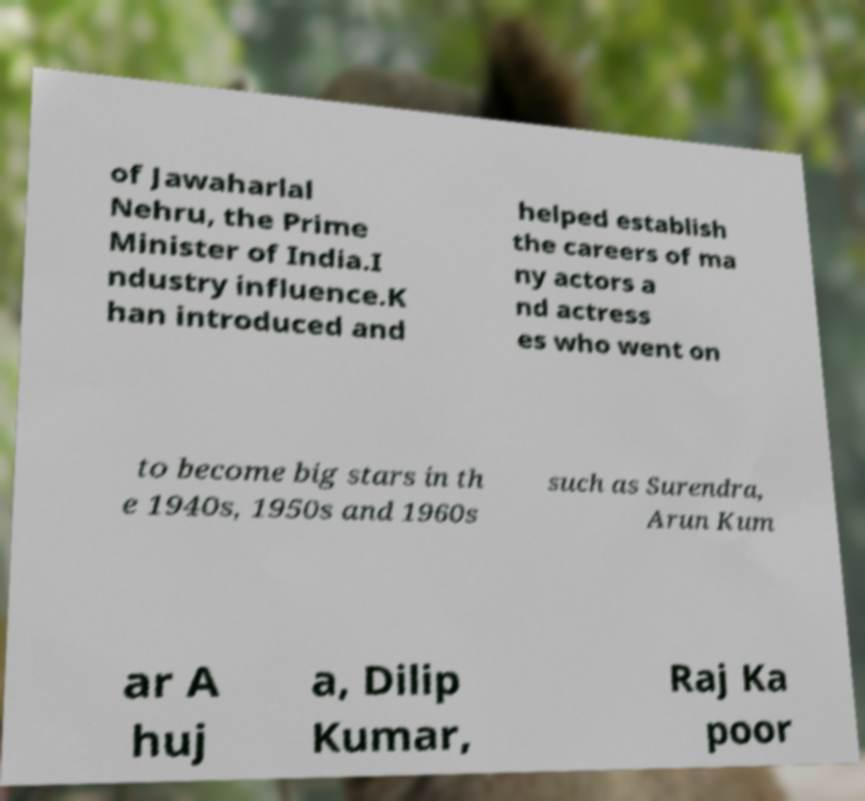Could you extract and type out the text from this image? of Jawaharlal Nehru, the Prime Minister of India.I ndustry influence.K han introduced and helped establish the careers of ma ny actors a nd actress es who went on to become big stars in th e 1940s, 1950s and 1960s such as Surendra, Arun Kum ar A huj a, Dilip Kumar, Raj Ka poor 